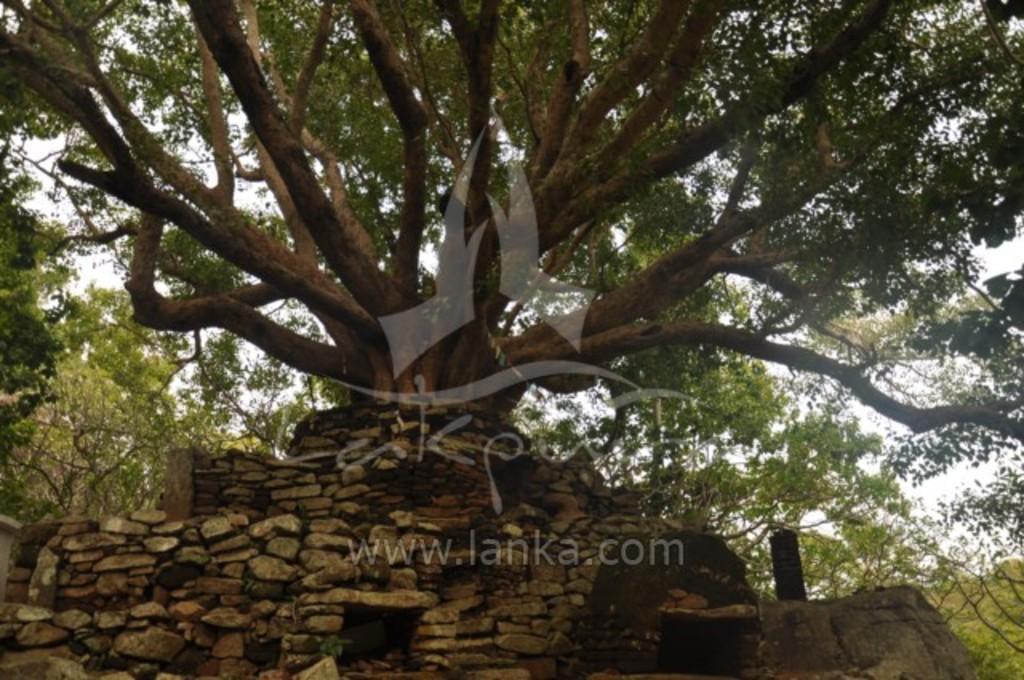Please provide a concise description of this image. In this image we can see trees, also we can see the wall, and the sky, and there are text on the image. 